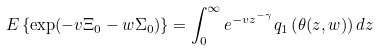Convert formula to latex. <formula><loc_0><loc_0><loc_500><loc_500>E \left \{ \exp ( - v \Xi _ { 0 } - w \Sigma _ { 0 } ) \right \} = \int _ { 0 } ^ { \infty } e ^ { - v z ^ { - \gamma } } q _ { 1 } \left ( \theta ( z , w ) \right ) d z</formula> 